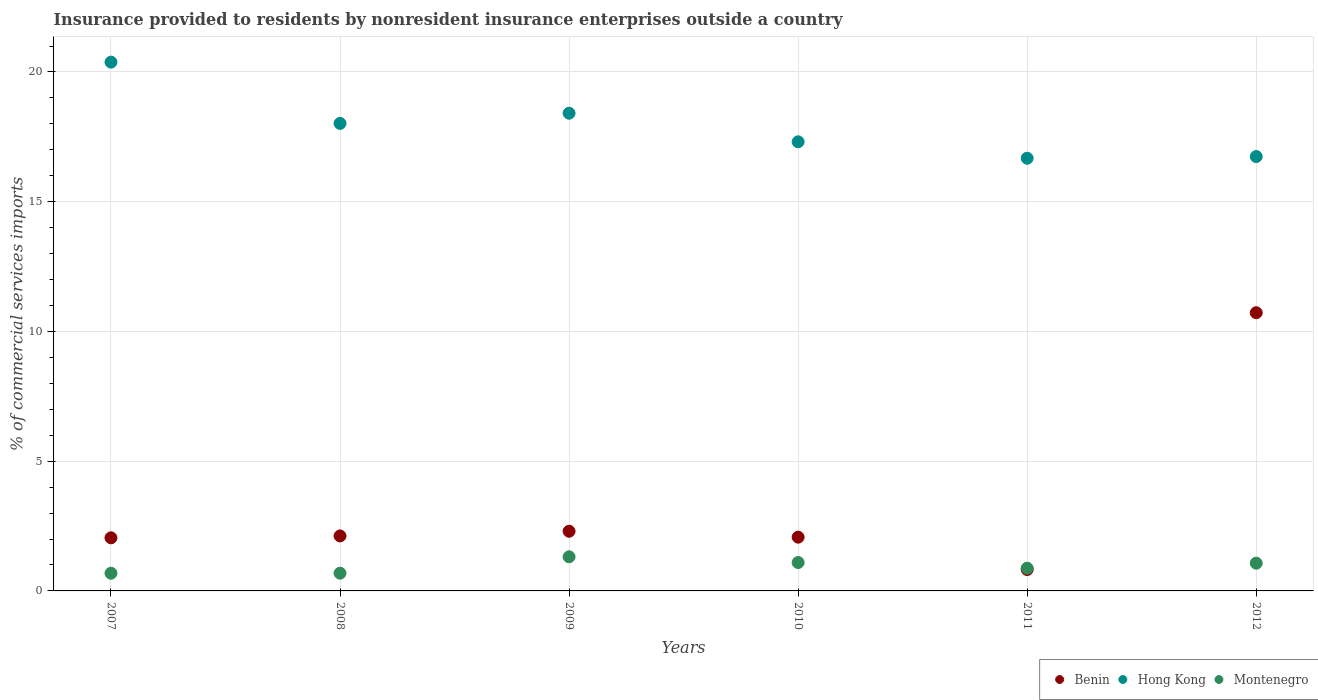Is the number of dotlines equal to the number of legend labels?
Offer a terse response. Yes. What is the Insurance provided to residents in Montenegro in 2007?
Provide a succinct answer. 0.68. Across all years, what is the maximum Insurance provided to residents in Hong Kong?
Ensure brevity in your answer.  20.38. Across all years, what is the minimum Insurance provided to residents in Montenegro?
Give a very brief answer. 0.68. In which year was the Insurance provided to residents in Hong Kong maximum?
Your answer should be very brief. 2007. In which year was the Insurance provided to residents in Montenegro minimum?
Ensure brevity in your answer.  2007. What is the total Insurance provided to residents in Benin in the graph?
Keep it short and to the point. 20.08. What is the difference between the Insurance provided to residents in Benin in 2009 and that in 2012?
Give a very brief answer. -8.42. What is the difference between the Insurance provided to residents in Hong Kong in 2008 and the Insurance provided to residents in Montenegro in 2012?
Keep it short and to the point. 16.95. What is the average Insurance provided to residents in Montenegro per year?
Ensure brevity in your answer.  0.95. In the year 2010, what is the difference between the Insurance provided to residents in Montenegro and Insurance provided to residents in Benin?
Give a very brief answer. -0.98. What is the ratio of the Insurance provided to residents in Hong Kong in 2007 to that in 2011?
Your answer should be very brief. 1.22. Is the difference between the Insurance provided to residents in Montenegro in 2009 and 2011 greater than the difference between the Insurance provided to residents in Benin in 2009 and 2011?
Make the answer very short. No. What is the difference between the highest and the second highest Insurance provided to residents in Benin?
Your answer should be compact. 8.42. What is the difference between the highest and the lowest Insurance provided to residents in Hong Kong?
Provide a short and direct response. 3.7. In how many years, is the Insurance provided to residents in Hong Kong greater than the average Insurance provided to residents in Hong Kong taken over all years?
Make the answer very short. 3. Is it the case that in every year, the sum of the Insurance provided to residents in Montenegro and Insurance provided to residents in Hong Kong  is greater than the Insurance provided to residents in Benin?
Provide a short and direct response. Yes. How many dotlines are there?
Offer a very short reply. 3. How many years are there in the graph?
Your response must be concise. 6. Does the graph contain any zero values?
Offer a terse response. No. Does the graph contain grids?
Offer a very short reply. Yes. What is the title of the graph?
Make the answer very short. Insurance provided to residents by nonresident insurance enterprises outside a country. Does "Lithuania" appear as one of the legend labels in the graph?
Offer a very short reply. No. What is the label or title of the Y-axis?
Keep it short and to the point. % of commercial services imports. What is the % of commercial services imports of Benin in 2007?
Provide a succinct answer. 2.05. What is the % of commercial services imports of Hong Kong in 2007?
Your answer should be very brief. 20.38. What is the % of commercial services imports in Montenegro in 2007?
Ensure brevity in your answer.  0.68. What is the % of commercial services imports of Benin in 2008?
Make the answer very short. 2.12. What is the % of commercial services imports of Hong Kong in 2008?
Ensure brevity in your answer.  18.02. What is the % of commercial services imports in Montenegro in 2008?
Offer a terse response. 0.68. What is the % of commercial services imports of Benin in 2009?
Make the answer very short. 2.3. What is the % of commercial services imports in Hong Kong in 2009?
Offer a terse response. 18.41. What is the % of commercial services imports of Montenegro in 2009?
Offer a terse response. 1.31. What is the % of commercial services imports in Benin in 2010?
Ensure brevity in your answer.  2.07. What is the % of commercial services imports of Hong Kong in 2010?
Offer a very short reply. 17.31. What is the % of commercial services imports of Montenegro in 2010?
Your answer should be very brief. 1.09. What is the % of commercial services imports of Benin in 2011?
Offer a very short reply. 0.82. What is the % of commercial services imports in Hong Kong in 2011?
Make the answer very short. 16.68. What is the % of commercial services imports in Montenegro in 2011?
Your answer should be very brief. 0.88. What is the % of commercial services imports of Benin in 2012?
Your response must be concise. 10.72. What is the % of commercial services imports of Hong Kong in 2012?
Your response must be concise. 16.74. What is the % of commercial services imports of Montenegro in 2012?
Your answer should be compact. 1.07. Across all years, what is the maximum % of commercial services imports in Benin?
Offer a terse response. 10.72. Across all years, what is the maximum % of commercial services imports in Hong Kong?
Offer a terse response. 20.38. Across all years, what is the maximum % of commercial services imports in Montenegro?
Provide a succinct answer. 1.31. Across all years, what is the minimum % of commercial services imports of Benin?
Your answer should be very brief. 0.82. Across all years, what is the minimum % of commercial services imports of Hong Kong?
Make the answer very short. 16.68. Across all years, what is the minimum % of commercial services imports in Montenegro?
Offer a very short reply. 0.68. What is the total % of commercial services imports in Benin in the graph?
Provide a succinct answer. 20.08. What is the total % of commercial services imports in Hong Kong in the graph?
Provide a short and direct response. 107.53. What is the total % of commercial services imports of Montenegro in the graph?
Make the answer very short. 5.72. What is the difference between the % of commercial services imports of Benin in 2007 and that in 2008?
Give a very brief answer. -0.07. What is the difference between the % of commercial services imports in Hong Kong in 2007 and that in 2008?
Provide a succinct answer. 2.36. What is the difference between the % of commercial services imports of Montenegro in 2007 and that in 2008?
Give a very brief answer. -0. What is the difference between the % of commercial services imports of Benin in 2007 and that in 2009?
Provide a short and direct response. -0.25. What is the difference between the % of commercial services imports in Hong Kong in 2007 and that in 2009?
Offer a terse response. 1.97. What is the difference between the % of commercial services imports in Montenegro in 2007 and that in 2009?
Provide a succinct answer. -0.63. What is the difference between the % of commercial services imports of Benin in 2007 and that in 2010?
Make the answer very short. -0.03. What is the difference between the % of commercial services imports of Hong Kong in 2007 and that in 2010?
Provide a short and direct response. 3.07. What is the difference between the % of commercial services imports in Montenegro in 2007 and that in 2010?
Give a very brief answer. -0.41. What is the difference between the % of commercial services imports of Benin in 2007 and that in 2011?
Keep it short and to the point. 1.22. What is the difference between the % of commercial services imports in Hong Kong in 2007 and that in 2011?
Your answer should be compact. 3.7. What is the difference between the % of commercial services imports in Montenegro in 2007 and that in 2011?
Offer a very short reply. -0.19. What is the difference between the % of commercial services imports of Benin in 2007 and that in 2012?
Make the answer very short. -8.68. What is the difference between the % of commercial services imports of Hong Kong in 2007 and that in 2012?
Offer a terse response. 3.64. What is the difference between the % of commercial services imports in Montenegro in 2007 and that in 2012?
Provide a succinct answer. -0.39. What is the difference between the % of commercial services imports in Benin in 2008 and that in 2009?
Make the answer very short. -0.18. What is the difference between the % of commercial services imports in Hong Kong in 2008 and that in 2009?
Your answer should be very brief. -0.39. What is the difference between the % of commercial services imports of Montenegro in 2008 and that in 2009?
Give a very brief answer. -0.63. What is the difference between the % of commercial services imports in Benin in 2008 and that in 2010?
Provide a short and direct response. 0.05. What is the difference between the % of commercial services imports in Hong Kong in 2008 and that in 2010?
Your answer should be very brief. 0.71. What is the difference between the % of commercial services imports of Montenegro in 2008 and that in 2010?
Provide a short and direct response. -0.41. What is the difference between the % of commercial services imports in Benin in 2008 and that in 2011?
Your answer should be very brief. 1.29. What is the difference between the % of commercial services imports of Hong Kong in 2008 and that in 2011?
Your answer should be compact. 1.34. What is the difference between the % of commercial services imports of Montenegro in 2008 and that in 2011?
Offer a very short reply. -0.19. What is the difference between the % of commercial services imports of Benin in 2008 and that in 2012?
Your response must be concise. -8.6. What is the difference between the % of commercial services imports of Hong Kong in 2008 and that in 2012?
Offer a very short reply. 1.28. What is the difference between the % of commercial services imports of Montenegro in 2008 and that in 2012?
Give a very brief answer. -0.39. What is the difference between the % of commercial services imports in Benin in 2009 and that in 2010?
Your answer should be very brief. 0.23. What is the difference between the % of commercial services imports in Hong Kong in 2009 and that in 2010?
Make the answer very short. 1.1. What is the difference between the % of commercial services imports in Montenegro in 2009 and that in 2010?
Provide a short and direct response. 0.22. What is the difference between the % of commercial services imports of Benin in 2009 and that in 2011?
Your response must be concise. 1.47. What is the difference between the % of commercial services imports in Hong Kong in 2009 and that in 2011?
Ensure brevity in your answer.  1.74. What is the difference between the % of commercial services imports of Montenegro in 2009 and that in 2011?
Your response must be concise. 0.44. What is the difference between the % of commercial services imports in Benin in 2009 and that in 2012?
Provide a short and direct response. -8.42. What is the difference between the % of commercial services imports in Hong Kong in 2009 and that in 2012?
Offer a very short reply. 1.67. What is the difference between the % of commercial services imports in Montenegro in 2009 and that in 2012?
Your response must be concise. 0.25. What is the difference between the % of commercial services imports in Benin in 2010 and that in 2011?
Make the answer very short. 1.25. What is the difference between the % of commercial services imports in Hong Kong in 2010 and that in 2011?
Ensure brevity in your answer.  0.63. What is the difference between the % of commercial services imports of Montenegro in 2010 and that in 2011?
Ensure brevity in your answer.  0.22. What is the difference between the % of commercial services imports of Benin in 2010 and that in 2012?
Give a very brief answer. -8.65. What is the difference between the % of commercial services imports of Hong Kong in 2010 and that in 2012?
Your answer should be compact. 0.57. What is the difference between the % of commercial services imports of Montenegro in 2010 and that in 2012?
Your response must be concise. 0.03. What is the difference between the % of commercial services imports of Benin in 2011 and that in 2012?
Your answer should be very brief. -9.9. What is the difference between the % of commercial services imports of Hong Kong in 2011 and that in 2012?
Make the answer very short. -0.07. What is the difference between the % of commercial services imports of Montenegro in 2011 and that in 2012?
Give a very brief answer. -0.19. What is the difference between the % of commercial services imports in Benin in 2007 and the % of commercial services imports in Hong Kong in 2008?
Your answer should be compact. -15.97. What is the difference between the % of commercial services imports of Benin in 2007 and the % of commercial services imports of Montenegro in 2008?
Provide a short and direct response. 1.36. What is the difference between the % of commercial services imports of Hong Kong in 2007 and the % of commercial services imports of Montenegro in 2008?
Offer a very short reply. 19.7. What is the difference between the % of commercial services imports in Benin in 2007 and the % of commercial services imports in Hong Kong in 2009?
Your answer should be very brief. -16.36. What is the difference between the % of commercial services imports in Benin in 2007 and the % of commercial services imports in Montenegro in 2009?
Your answer should be very brief. 0.73. What is the difference between the % of commercial services imports in Hong Kong in 2007 and the % of commercial services imports in Montenegro in 2009?
Your response must be concise. 19.07. What is the difference between the % of commercial services imports in Benin in 2007 and the % of commercial services imports in Hong Kong in 2010?
Your response must be concise. -15.26. What is the difference between the % of commercial services imports of Benin in 2007 and the % of commercial services imports of Montenegro in 2010?
Offer a very short reply. 0.95. What is the difference between the % of commercial services imports of Hong Kong in 2007 and the % of commercial services imports of Montenegro in 2010?
Offer a terse response. 19.29. What is the difference between the % of commercial services imports in Benin in 2007 and the % of commercial services imports in Hong Kong in 2011?
Give a very brief answer. -14.63. What is the difference between the % of commercial services imports of Benin in 2007 and the % of commercial services imports of Montenegro in 2011?
Your response must be concise. 1.17. What is the difference between the % of commercial services imports of Hong Kong in 2007 and the % of commercial services imports of Montenegro in 2011?
Make the answer very short. 19.5. What is the difference between the % of commercial services imports in Benin in 2007 and the % of commercial services imports in Hong Kong in 2012?
Provide a succinct answer. -14.69. What is the difference between the % of commercial services imports in Benin in 2007 and the % of commercial services imports in Montenegro in 2012?
Offer a terse response. 0.98. What is the difference between the % of commercial services imports of Hong Kong in 2007 and the % of commercial services imports of Montenegro in 2012?
Ensure brevity in your answer.  19.31. What is the difference between the % of commercial services imports of Benin in 2008 and the % of commercial services imports of Hong Kong in 2009?
Provide a short and direct response. -16.29. What is the difference between the % of commercial services imports of Benin in 2008 and the % of commercial services imports of Montenegro in 2009?
Offer a terse response. 0.8. What is the difference between the % of commercial services imports of Hong Kong in 2008 and the % of commercial services imports of Montenegro in 2009?
Your answer should be very brief. 16.7. What is the difference between the % of commercial services imports of Benin in 2008 and the % of commercial services imports of Hong Kong in 2010?
Give a very brief answer. -15.19. What is the difference between the % of commercial services imports of Benin in 2008 and the % of commercial services imports of Montenegro in 2010?
Make the answer very short. 1.02. What is the difference between the % of commercial services imports of Hong Kong in 2008 and the % of commercial services imports of Montenegro in 2010?
Keep it short and to the point. 16.92. What is the difference between the % of commercial services imports in Benin in 2008 and the % of commercial services imports in Hong Kong in 2011?
Keep it short and to the point. -14.56. What is the difference between the % of commercial services imports in Benin in 2008 and the % of commercial services imports in Montenegro in 2011?
Ensure brevity in your answer.  1.24. What is the difference between the % of commercial services imports of Hong Kong in 2008 and the % of commercial services imports of Montenegro in 2011?
Offer a very short reply. 17.14. What is the difference between the % of commercial services imports of Benin in 2008 and the % of commercial services imports of Hong Kong in 2012?
Offer a very short reply. -14.62. What is the difference between the % of commercial services imports of Benin in 2008 and the % of commercial services imports of Montenegro in 2012?
Keep it short and to the point. 1.05. What is the difference between the % of commercial services imports in Hong Kong in 2008 and the % of commercial services imports in Montenegro in 2012?
Your answer should be compact. 16.95. What is the difference between the % of commercial services imports in Benin in 2009 and the % of commercial services imports in Hong Kong in 2010?
Give a very brief answer. -15.01. What is the difference between the % of commercial services imports in Benin in 2009 and the % of commercial services imports in Montenegro in 2010?
Make the answer very short. 1.2. What is the difference between the % of commercial services imports of Hong Kong in 2009 and the % of commercial services imports of Montenegro in 2010?
Provide a short and direct response. 17.32. What is the difference between the % of commercial services imports of Benin in 2009 and the % of commercial services imports of Hong Kong in 2011?
Ensure brevity in your answer.  -14.38. What is the difference between the % of commercial services imports in Benin in 2009 and the % of commercial services imports in Montenegro in 2011?
Your response must be concise. 1.42. What is the difference between the % of commercial services imports of Hong Kong in 2009 and the % of commercial services imports of Montenegro in 2011?
Offer a very short reply. 17.53. What is the difference between the % of commercial services imports in Benin in 2009 and the % of commercial services imports in Hong Kong in 2012?
Offer a very short reply. -14.44. What is the difference between the % of commercial services imports of Benin in 2009 and the % of commercial services imports of Montenegro in 2012?
Ensure brevity in your answer.  1.23. What is the difference between the % of commercial services imports of Hong Kong in 2009 and the % of commercial services imports of Montenegro in 2012?
Provide a succinct answer. 17.34. What is the difference between the % of commercial services imports of Benin in 2010 and the % of commercial services imports of Hong Kong in 2011?
Ensure brevity in your answer.  -14.6. What is the difference between the % of commercial services imports of Benin in 2010 and the % of commercial services imports of Montenegro in 2011?
Offer a terse response. 1.19. What is the difference between the % of commercial services imports of Hong Kong in 2010 and the % of commercial services imports of Montenegro in 2011?
Provide a short and direct response. 16.43. What is the difference between the % of commercial services imports of Benin in 2010 and the % of commercial services imports of Hong Kong in 2012?
Give a very brief answer. -14.67. What is the difference between the % of commercial services imports in Hong Kong in 2010 and the % of commercial services imports in Montenegro in 2012?
Keep it short and to the point. 16.24. What is the difference between the % of commercial services imports in Benin in 2011 and the % of commercial services imports in Hong Kong in 2012?
Ensure brevity in your answer.  -15.92. What is the difference between the % of commercial services imports of Benin in 2011 and the % of commercial services imports of Montenegro in 2012?
Offer a very short reply. -0.24. What is the difference between the % of commercial services imports of Hong Kong in 2011 and the % of commercial services imports of Montenegro in 2012?
Offer a very short reply. 15.61. What is the average % of commercial services imports in Benin per year?
Your response must be concise. 3.35. What is the average % of commercial services imports in Hong Kong per year?
Your answer should be compact. 17.92. What is the average % of commercial services imports of Montenegro per year?
Provide a succinct answer. 0.95. In the year 2007, what is the difference between the % of commercial services imports of Benin and % of commercial services imports of Hong Kong?
Your answer should be compact. -18.33. In the year 2007, what is the difference between the % of commercial services imports of Benin and % of commercial services imports of Montenegro?
Provide a succinct answer. 1.36. In the year 2007, what is the difference between the % of commercial services imports of Hong Kong and % of commercial services imports of Montenegro?
Provide a succinct answer. 19.7. In the year 2008, what is the difference between the % of commercial services imports of Benin and % of commercial services imports of Hong Kong?
Make the answer very short. -15.9. In the year 2008, what is the difference between the % of commercial services imports in Benin and % of commercial services imports in Montenegro?
Provide a short and direct response. 1.44. In the year 2008, what is the difference between the % of commercial services imports of Hong Kong and % of commercial services imports of Montenegro?
Give a very brief answer. 17.34. In the year 2009, what is the difference between the % of commercial services imports of Benin and % of commercial services imports of Hong Kong?
Your answer should be very brief. -16.11. In the year 2009, what is the difference between the % of commercial services imports in Benin and % of commercial services imports in Montenegro?
Offer a very short reply. 0.98. In the year 2009, what is the difference between the % of commercial services imports of Hong Kong and % of commercial services imports of Montenegro?
Your answer should be very brief. 17.1. In the year 2010, what is the difference between the % of commercial services imports in Benin and % of commercial services imports in Hong Kong?
Your answer should be very brief. -15.24. In the year 2010, what is the difference between the % of commercial services imports of Benin and % of commercial services imports of Montenegro?
Provide a short and direct response. 0.98. In the year 2010, what is the difference between the % of commercial services imports in Hong Kong and % of commercial services imports in Montenegro?
Your response must be concise. 16.21. In the year 2011, what is the difference between the % of commercial services imports of Benin and % of commercial services imports of Hong Kong?
Make the answer very short. -15.85. In the year 2011, what is the difference between the % of commercial services imports of Benin and % of commercial services imports of Montenegro?
Provide a short and direct response. -0.05. In the year 2011, what is the difference between the % of commercial services imports of Hong Kong and % of commercial services imports of Montenegro?
Make the answer very short. 15.8. In the year 2012, what is the difference between the % of commercial services imports in Benin and % of commercial services imports in Hong Kong?
Keep it short and to the point. -6.02. In the year 2012, what is the difference between the % of commercial services imports in Benin and % of commercial services imports in Montenegro?
Your response must be concise. 9.65. In the year 2012, what is the difference between the % of commercial services imports in Hong Kong and % of commercial services imports in Montenegro?
Provide a short and direct response. 15.67. What is the ratio of the % of commercial services imports in Benin in 2007 to that in 2008?
Provide a short and direct response. 0.97. What is the ratio of the % of commercial services imports in Hong Kong in 2007 to that in 2008?
Offer a terse response. 1.13. What is the ratio of the % of commercial services imports of Montenegro in 2007 to that in 2008?
Your response must be concise. 1. What is the ratio of the % of commercial services imports of Benin in 2007 to that in 2009?
Your answer should be compact. 0.89. What is the ratio of the % of commercial services imports of Hong Kong in 2007 to that in 2009?
Offer a very short reply. 1.11. What is the ratio of the % of commercial services imports in Montenegro in 2007 to that in 2009?
Your response must be concise. 0.52. What is the ratio of the % of commercial services imports of Benin in 2007 to that in 2010?
Offer a terse response. 0.99. What is the ratio of the % of commercial services imports in Hong Kong in 2007 to that in 2010?
Keep it short and to the point. 1.18. What is the ratio of the % of commercial services imports of Montenegro in 2007 to that in 2010?
Offer a very short reply. 0.62. What is the ratio of the % of commercial services imports in Benin in 2007 to that in 2011?
Provide a short and direct response. 2.48. What is the ratio of the % of commercial services imports of Hong Kong in 2007 to that in 2011?
Make the answer very short. 1.22. What is the ratio of the % of commercial services imports in Montenegro in 2007 to that in 2011?
Provide a short and direct response. 0.78. What is the ratio of the % of commercial services imports of Benin in 2007 to that in 2012?
Provide a short and direct response. 0.19. What is the ratio of the % of commercial services imports in Hong Kong in 2007 to that in 2012?
Provide a succinct answer. 1.22. What is the ratio of the % of commercial services imports of Montenegro in 2007 to that in 2012?
Your response must be concise. 0.64. What is the ratio of the % of commercial services imports in Benin in 2008 to that in 2009?
Your response must be concise. 0.92. What is the ratio of the % of commercial services imports of Hong Kong in 2008 to that in 2009?
Your answer should be very brief. 0.98. What is the ratio of the % of commercial services imports in Montenegro in 2008 to that in 2009?
Provide a succinct answer. 0.52. What is the ratio of the % of commercial services imports of Benin in 2008 to that in 2010?
Give a very brief answer. 1.02. What is the ratio of the % of commercial services imports of Hong Kong in 2008 to that in 2010?
Offer a very short reply. 1.04. What is the ratio of the % of commercial services imports of Montenegro in 2008 to that in 2010?
Your response must be concise. 0.62. What is the ratio of the % of commercial services imports in Benin in 2008 to that in 2011?
Make the answer very short. 2.57. What is the ratio of the % of commercial services imports of Hong Kong in 2008 to that in 2011?
Your response must be concise. 1.08. What is the ratio of the % of commercial services imports in Montenegro in 2008 to that in 2011?
Your response must be concise. 0.78. What is the ratio of the % of commercial services imports of Benin in 2008 to that in 2012?
Provide a succinct answer. 0.2. What is the ratio of the % of commercial services imports in Hong Kong in 2008 to that in 2012?
Give a very brief answer. 1.08. What is the ratio of the % of commercial services imports of Montenegro in 2008 to that in 2012?
Ensure brevity in your answer.  0.64. What is the ratio of the % of commercial services imports of Benin in 2009 to that in 2010?
Your response must be concise. 1.11. What is the ratio of the % of commercial services imports in Hong Kong in 2009 to that in 2010?
Make the answer very short. 1.06. What is the ratio of the % of commercial services imports in Montenegro in 2009 to that in 2010?
Offer a terse response. 1.2. What is the ratio of the % of commercial services imports of Benin in 2009 to that in 2011?
Your answer should be compact. 2.79. What is the ratio of the % of commercial services imports of Hong Kong in 2009 to that in 2011?
Your response must be concise. 1.1. What is the ratio of the % of commercial services imports of Montenegro in 2009 to that in 2011?
Your response must be concise. 1.5. What is the ratio of the % of commercial services imports in Benin in 2009 to that in 2012?
Keep it short and to the point. 0.21. What is the ratio of the % of commercial services imports of Hong Kong in 2009 to that in 2012?
Provide a succinct answer. 1.1. What is the ratio of the % of commercial services imports of Montenegro in 2009 to that in 2012?
Make the answer very short. 1.23. What is the ratio of the % of commercial services imports of Benin in 2010 to that in 2011?
Your answer should be very brief. 2.51. What is the ratio of the % of commercial services imports of Hong Kong in 2010 to that in 2011?
Keep it short and to the point. 1.04. What is the ratio of the % of commercial services imports of Montenegro in 2010 to that in 2011?
Provide a succinct answer. 1.25. What is the ratio of the % of commercial services imports in Benin in 2010 to that in 2012?
Make the answer very short. 0.19. What is the ratio of the % of commercial services imports in Hong Kong in 2010 to that in 2012?
Your answer should be very brief. 1.03. What is the ratio of the % of commercial services imports of Montenegro in 2010 to that in 2012?
Provide a succinct answer. 1.02. What is the ratio of the % of commercial services imports of Benin in 2011 to that in 2012?
Your answer should be compact. 0.08. What is the ratio of the % of commercial services imports in Hong Kong in 2011 to that in 2012?
Give a very brief answer. 1. What is the ratio of the % of commercial services imports of Montenegro in 2011 to that in 2012?
Make the answer very short. 0.82. What is the difference between the highest and the second highest % of commercial services imports of Benin?
Offer a terse response. 8.42. What is the difference between the highest and the second highest % of commercial services imports in Hong Kong?
Your response must be concise. 1.97. What is the difference between the highest and the second highest % of commercial services imports of Montenegro?
Your answer should be compact. 0.22. What is the difference between the highest and the lowest % of commercial services imports of Benin?
Provide a succinct answer. 9.9. What is the difference between the highest and the lowest % of commercial services imports of Hong Kong?
Your response must be concise. 3.7. What is the difference between the highest and the lowest % of commercial services imports of Montenegro?
Offer a terse response. 0.63. 